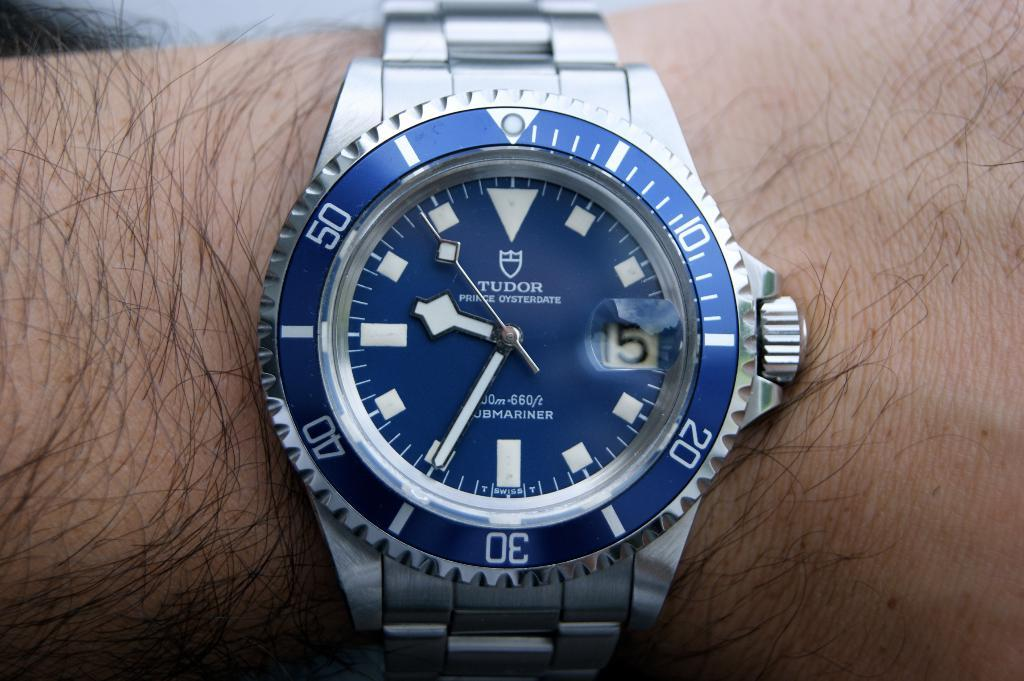<image>
Offer a succinct explanation of the picture presented. A Tudor brand watch features a blue colored face. 